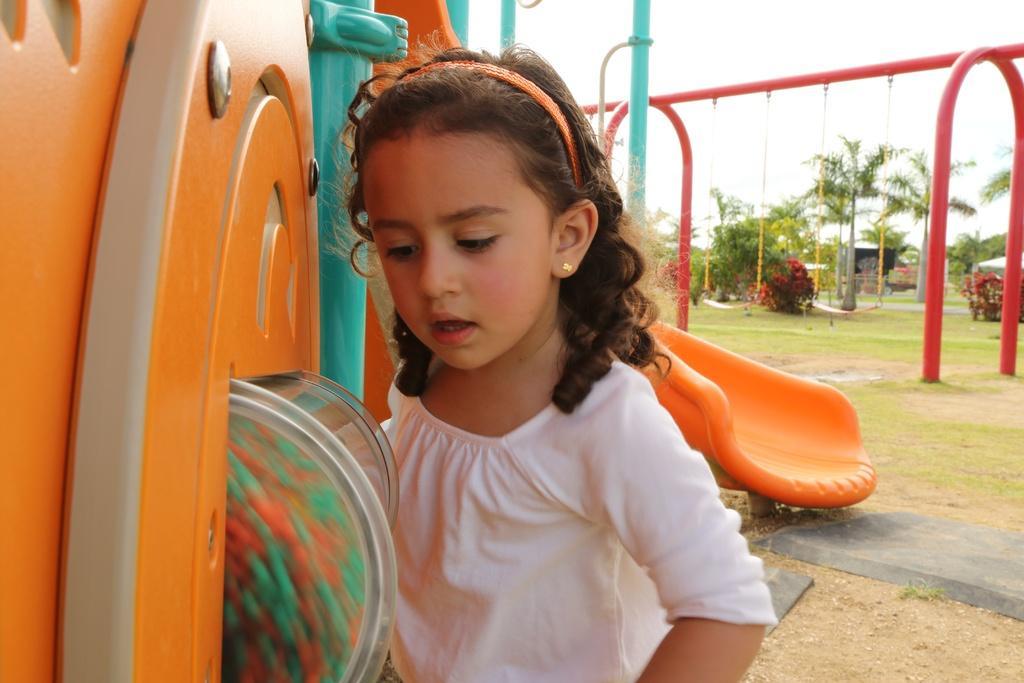Can you describe this image briefly? In this image we can see a park. There are many playing objects in the image. There is a sky in the image. There is a girl in the image. 